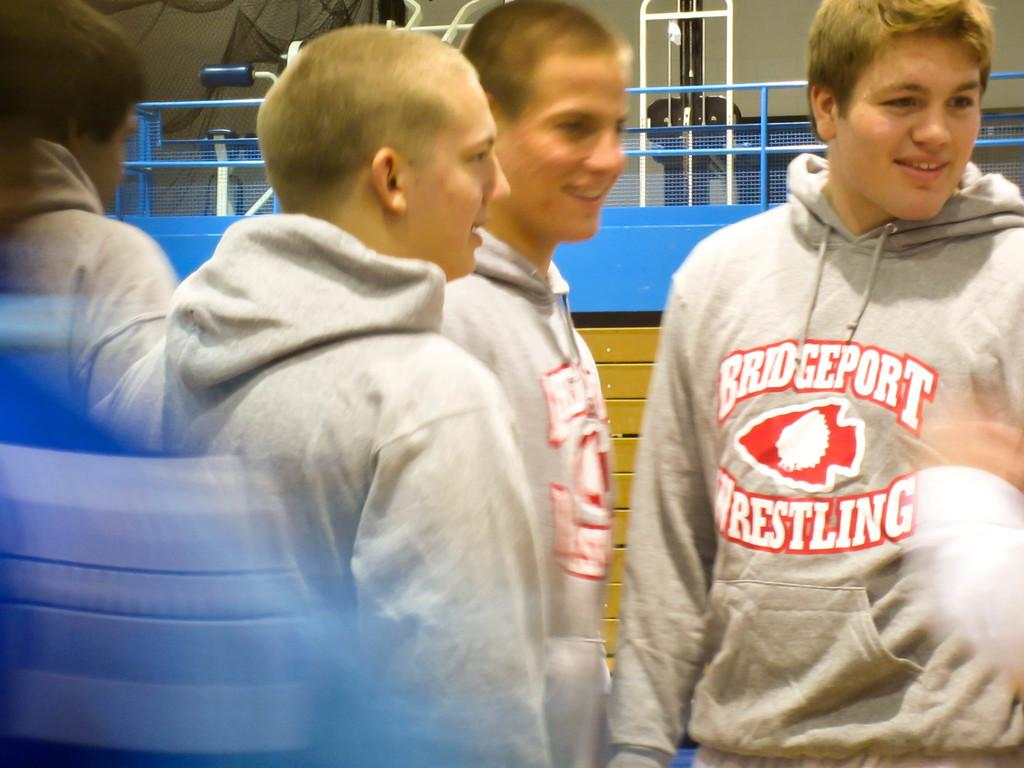<image>
Provide a brief description of the given image. a sweatshirt that has Bridgeport wrestling on their outfit 